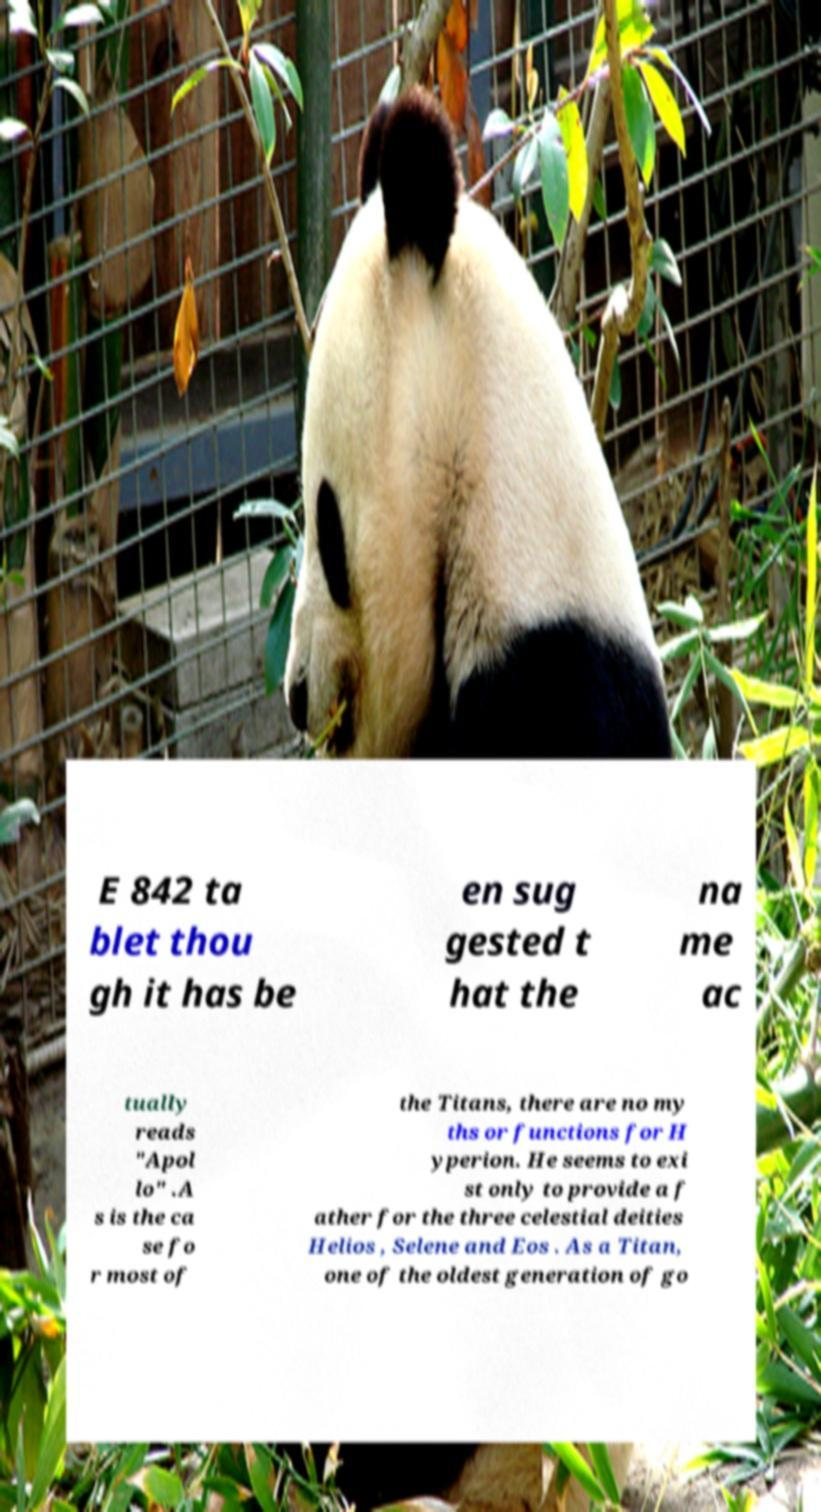For documentation purposes, I need the text within this image transcribed. Could you provide that? E 842 ta blet thou gh it has be en sug gested t hat the na me ac tually reads "Apol lo" .A s is the ca se fo r most of the Titans, there are no my ths or functions for H yperion. He seems to exi st only to provide a f ather for the three celestial deities Helios , Selene and Eos . As a Titan, one of the oldest generation of go 